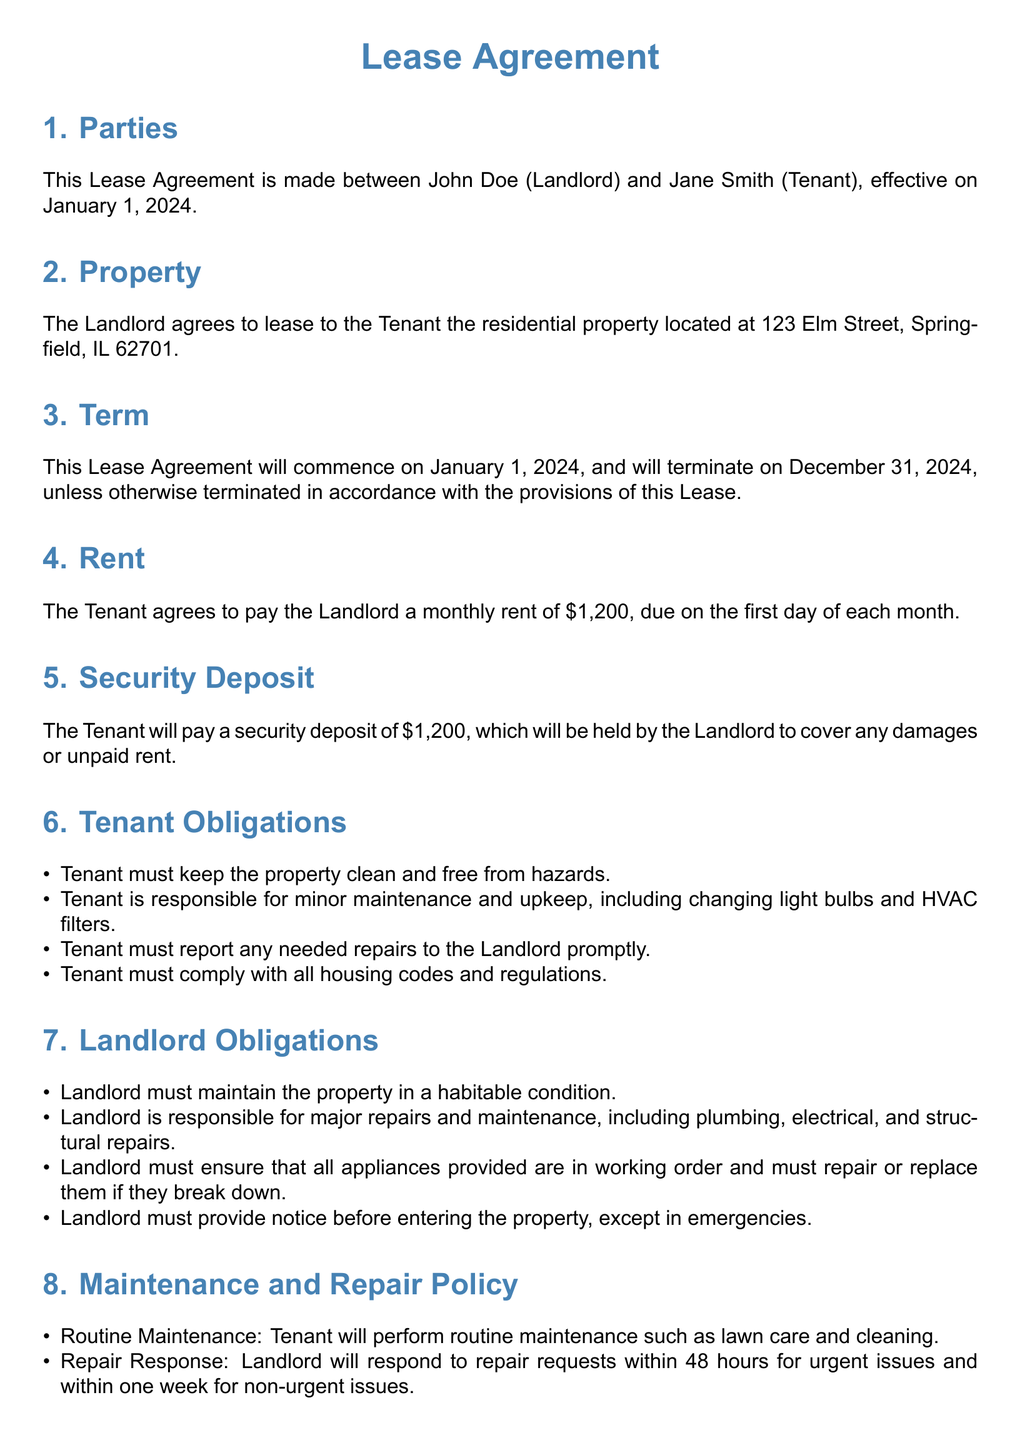What is the name of the Landlord? The Landlord is named John Doe as stated in the agreement.
Answer: John Doe What is the monthly rent amount? The monthly rent of the property is specified in the agreement as $1,200.
Answer: $1,200 When does the Lease Agreement begin? The effective date of the Lease Agreement is mentioned in Section 3.
Answer: January 1, 2024 Who is responsible for minor maintenance? The document specifies that the Tenant is responsible for minor maintenance.
Answer: Tenant How long does the Landlord have to respond to urgent repair requests? The document indicates that urgent repair requests must be addressed within 48 hours.
Answer: 48 hours What happens if the Tenant causes damage? The Lease Agreement states that the Tenant will be responsible for the cost of repairs if caused by negligence.
Answer: Responsible for cost Is the security deposit equal to the monthly rent? The security deposit amount is noted in the agreement and is equal to the monthly rent.
Answer: Yes How much notice is required to terminate the lease? The Lease Agreement specifies that a 30-day notice is required to terminate the lease.
Answer: 30 days What is the Landlord obligated to maintain? The Landlord is obligated to maintain the property in a habitable condition.
Answer: Habitable condition 